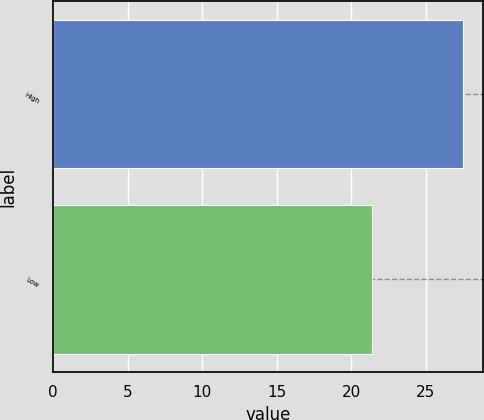Convert chart to OTSL. <chart><loc_0><loc_0><loc_500><loc_500><bar_chart><fcel>High<fcel>Low<nl><fcel>27.49<fcel>21.37<nl></chart> 